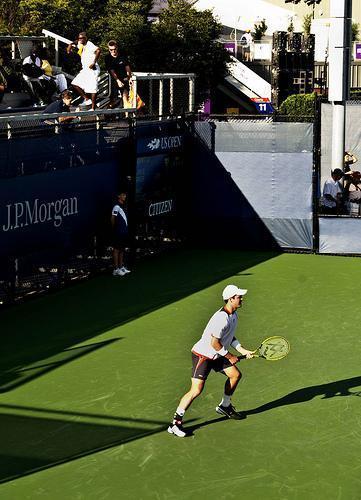How many rackets are in the man's hand?
Give a very brief answer. 1. 